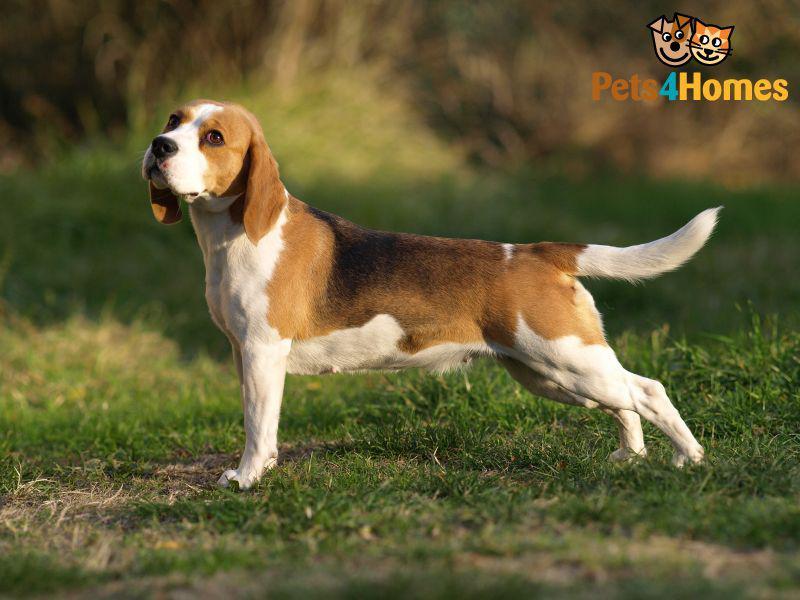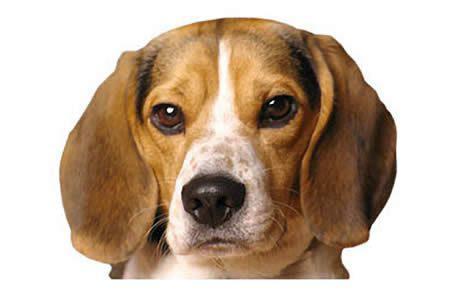The first image is the image on the left, the second image is the image on the right. For the images displayed, is the sentence "Each image contains exactly one beagle, and each dog is in approximately the same pose." factually correct? Answer yes or no. No. The first image is the image on the left, the second image is the image on the right. Analyze the images presented: Is the assertion "A single dog is standing on all fours in the image on the left." valid? Answer yes or no. Yes. 